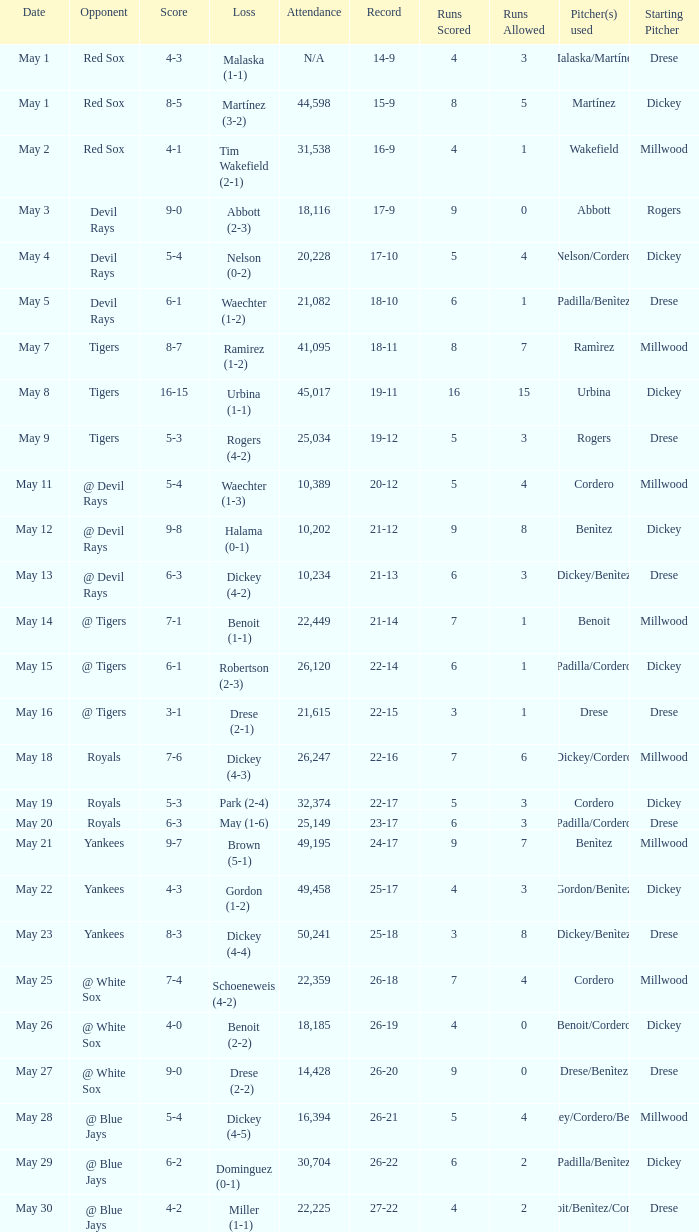What was the score of the game that had a loss of Drese (2-2)? 9-0. 